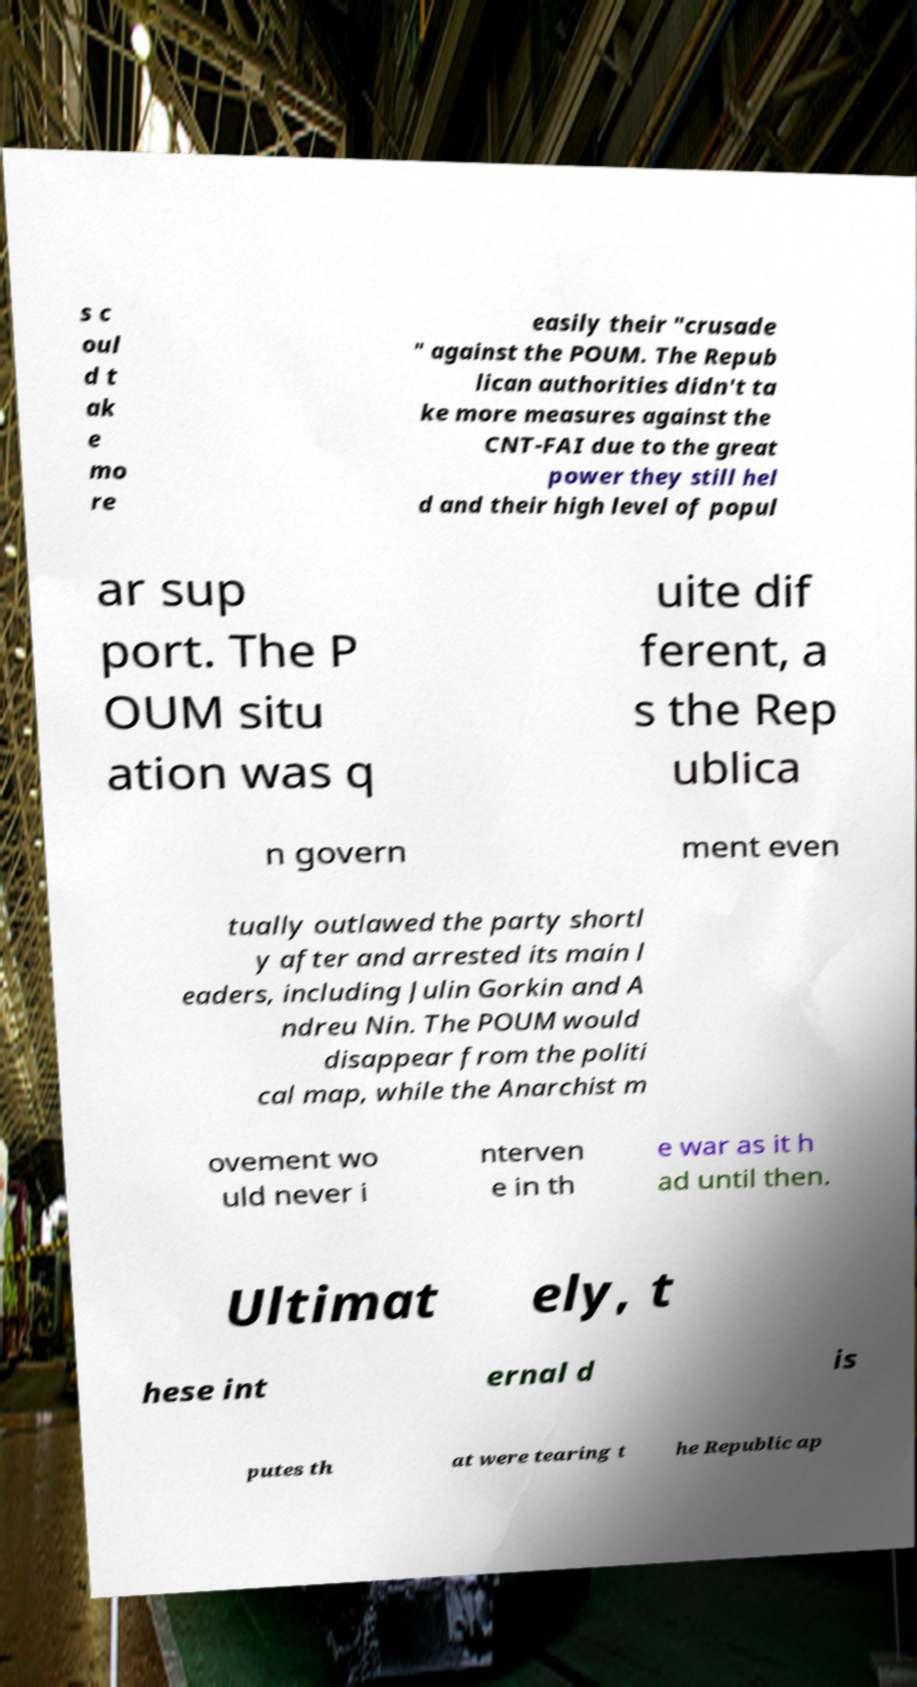I need the written content from this picture converted into text. Can you do that? s c oul d t ak e mo re easily their "crusade " against the POUM. The Repub lican authorities didn't ta ke more measures against the CNT-FAI due to the great power they still hel d and their high level of popul ar sup port. The P OUM situ ation was q uite dif ferent, a s the Rep ublica n govern ment even tually outlawed the party shortl y after and arrested its main l eaders, including Julin Gorkin and A ndreu Nin. The POUM would disappear from the politi cal map, while the Anarchist m ovement wo uld never i nterven e in th e war as it h ad until then. Ultimat ely, t hese int ernal d is putes th at were tearing t he Republic ap 